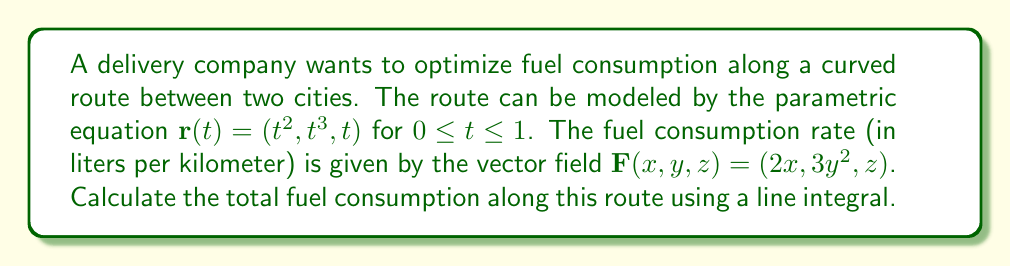Solve this math problem. To solve this problem, we need to evaluate the line integral of the vector field $\mathbf{F}$ along the curve $\mathbf{r}(t)$. We'll follow these steps:

1) The line integral is given by:
   $$\int_C \mathbf{F} \cdot d\mathbf{r} = \int_a^b \mathbf{F}(\mathbf{r}(t)) \cdot \mathbf{r}'(t) dt$$

2) We have:
   $\mathbf{r}(t) = (t^2, t^3, t)$
   $\mathbf{F}(x,y,z) = (2x, 3y^2, z)$

3) Calculate $\mathbf{r}'(t)$:
   $\mathbf{r}'(t) = (2t, 3t^2, 1)$

4) Evaluate $\mathbf{F}(\mathbf{r}(t))$:
   $\mathbf{F}(\mathbf{r}(t)) = (2t^2, 3t^6, t)$

5) Calculate the dot product $\mathbf{F}(\mathbf{r}(t)) \cdot \mathbf{r}'(t)$:
   $$(2t^2, 3t^6, t) \cdot (2t, 3t^2, 1) = 4t^3 + 9t^8 + t$$

6) Set up the integral:
   $$\int_0^1 (4t^3 + 9t^8 + t) dt$$

7) Integrate:
   $$\left[\frac{t^4}{1} + \frac{t^9}{1} + \frac{t^2}{2}\right]_0^1$$

8) Evaluate the integral:
   $$\left(1 + 1 + \frac{1}{2}\right) - \left(0 + 0 + 0\right) = \frac{5}{2}$$

Therefore, the total fuel consumption along this route is 2.5 liters.
Answer: 2.5 liters 